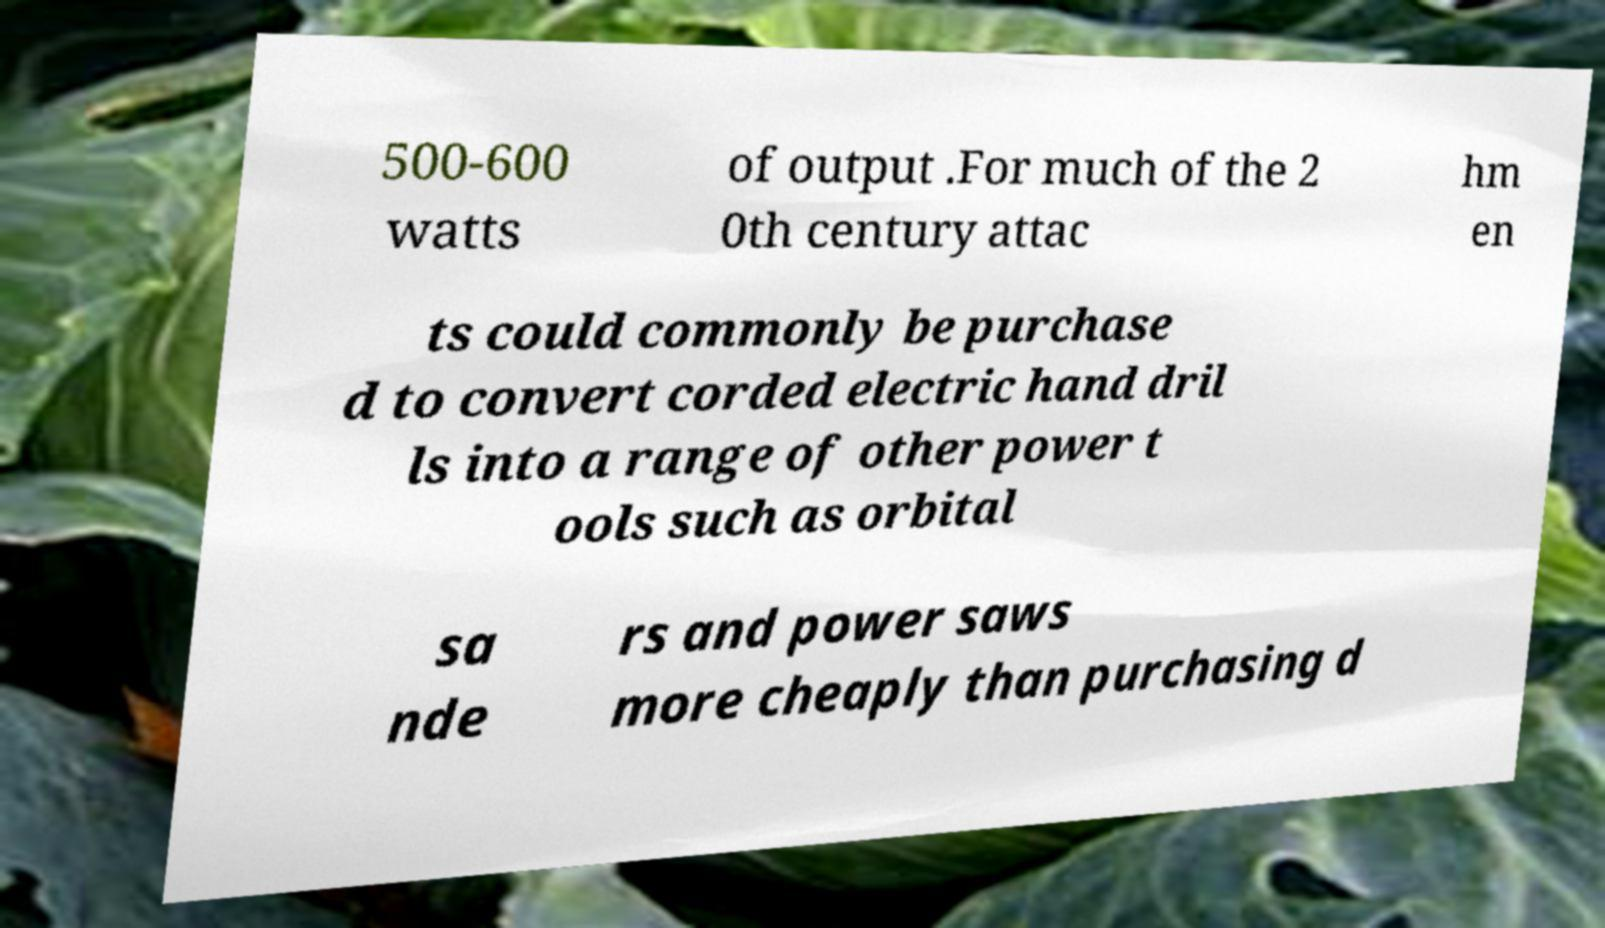Could you assist in decoding the text presented in this image and type it out clearly? 500-600 watts of output .For much of the 2 0th century attac hm en ts could commonly be purchase d to convert corded electric hand dril ls into a range of other power t ools such as orbital sa nde rs and power saws more cheaply than purchasing d 